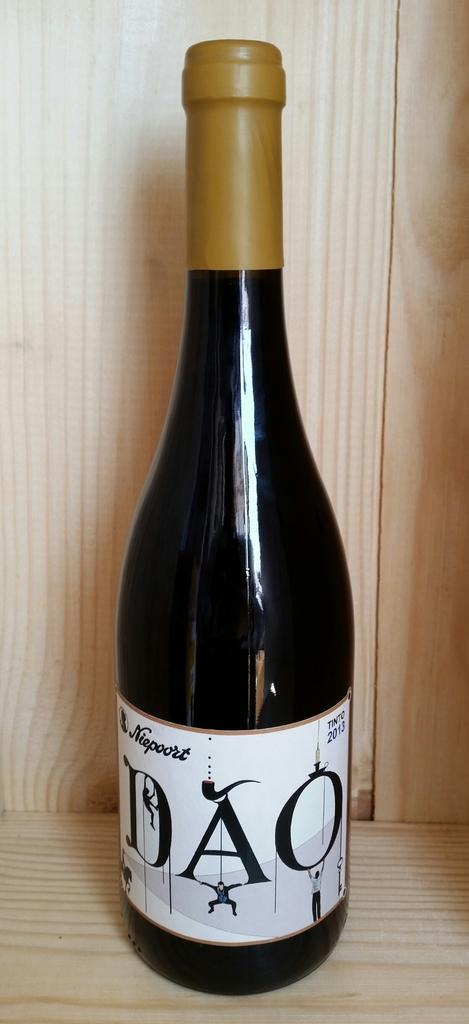<image>
Write a terse but informative summary of the picture. A bottle of DAO wine is sitting on a wooden shelf. 